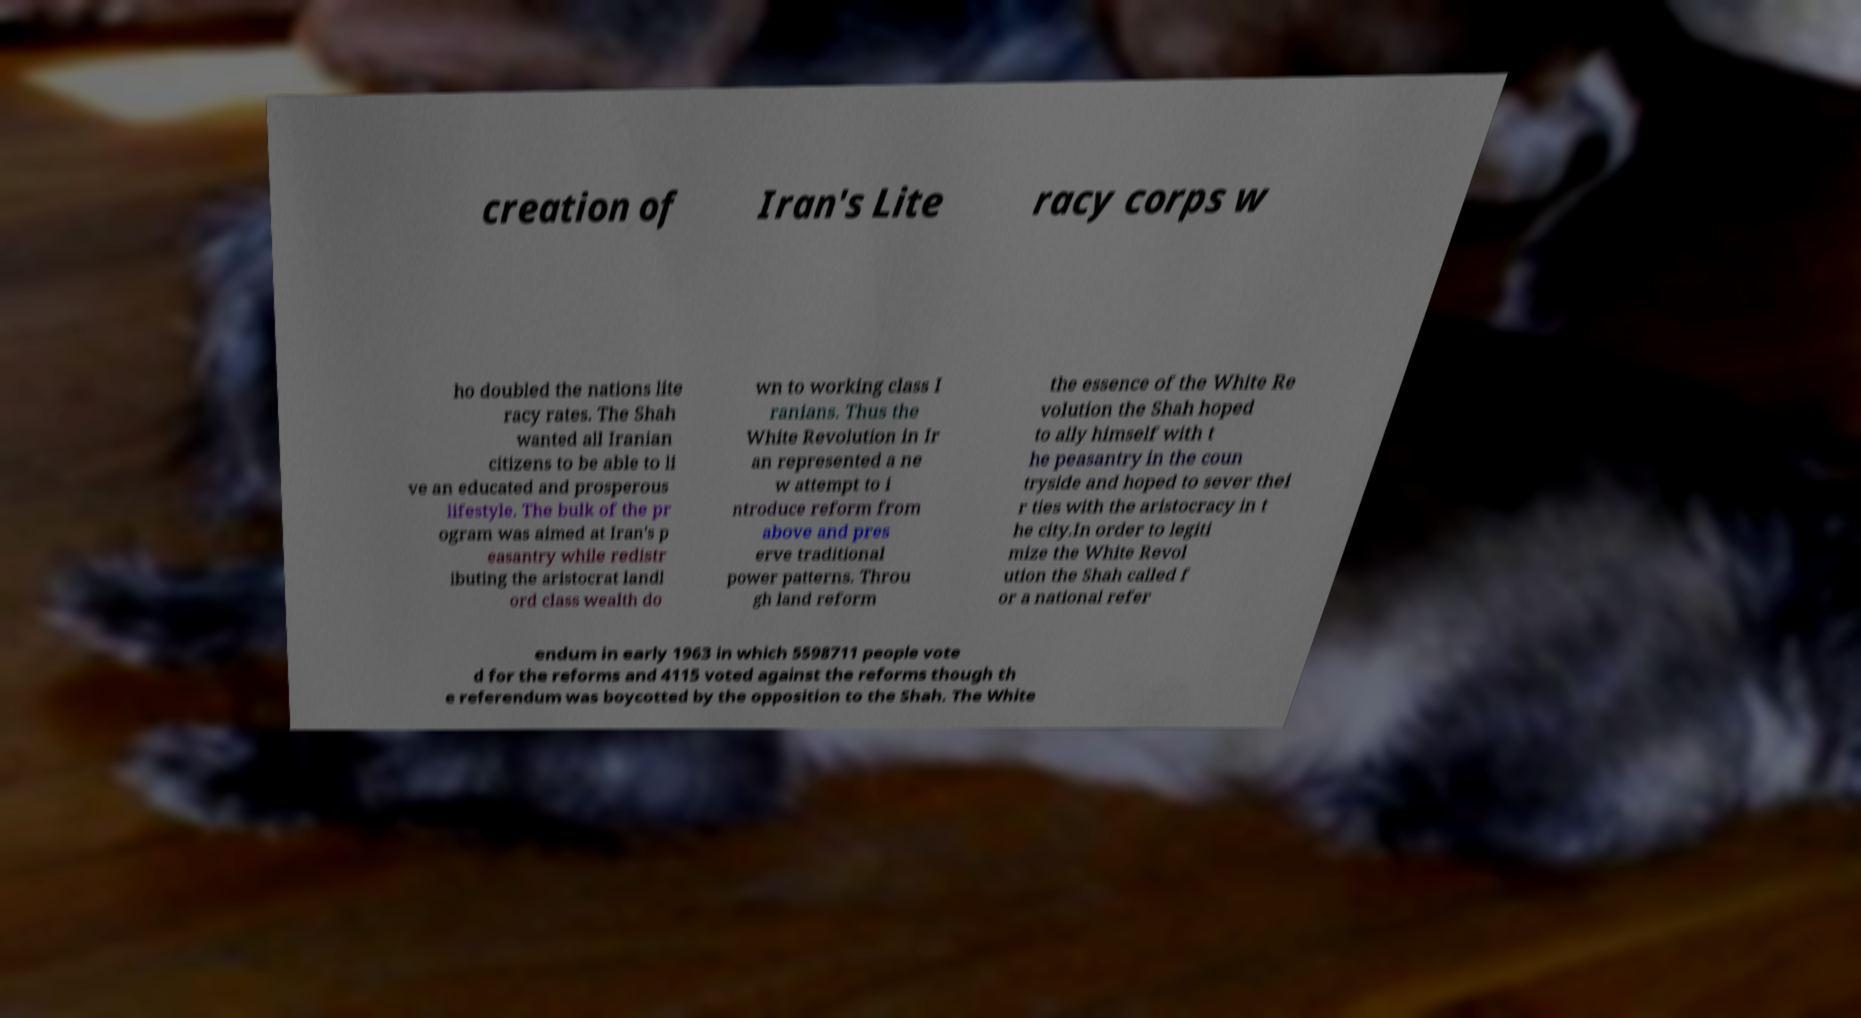I need the written content from this picture converted into text. Can you do that? creation of Iran's Lite racy corps w ho doubled the nations lite racy rates. The Shah wanted all Iranian citizens to be able to li ve an educated and prosperous lifestyle. The bulk of the pr ogram was aimed at Iran's p easantry while redistr ibuting the aristocrat landl ord class wealth do wn to working class I ranians. Thus the White Revolution in Ir an represented a ne w attempt to i ntroduce reform from above and pres erve traditional power patterns. Throu gh land reform the essence of the White Re volution the Shah hoped to ally himself with t he peasantry in the coun tryside and hoped to sever thei r ties with the aristocracy in t he city.In order to legiti mize the White Revol ution the Shah called f or a national refer endum in early 1963 in which 5598711 people vote d for the reforms and 4115 voted against the reforms though th e referendum was boycotted by the opposition to the Shah. The White 